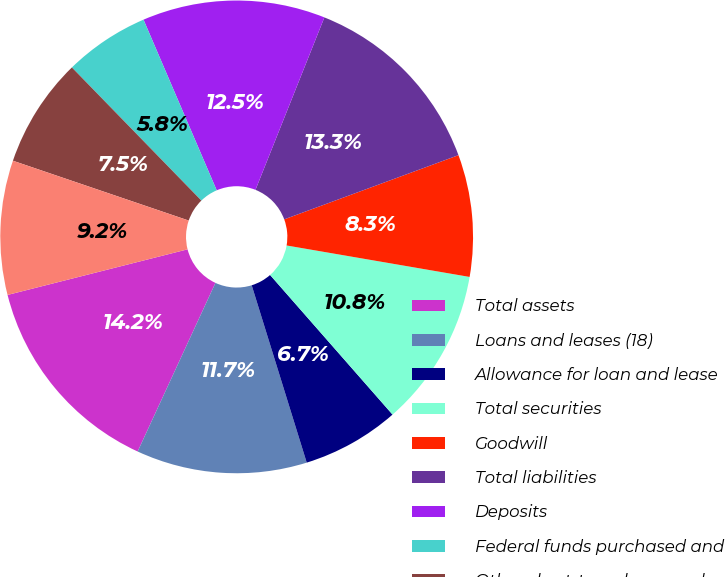<chart> <loc_0><loc_0><loc_500><loc_500><pie_chart><fcel>Total assets<fcel>Loans and leases (18)<fcel>Allowance for loan and lease<fcel>Total securities<fcel>Goodwill<fcel>Total liabilities<fcel>Deposits<fcel>Federal funds purchased and<fcel>Other short-term borrowed<fcel>Long-term borrowed funds<nl><fcel>14.17%<fcel>11.67%<fcel>6.67%<fcel>10.83%<fcel>8.33%<fcel>13.33%<fcel>12.5%<fcel>5.83%<fcel>7.5%<fcel>9.17%<nl></chart> 